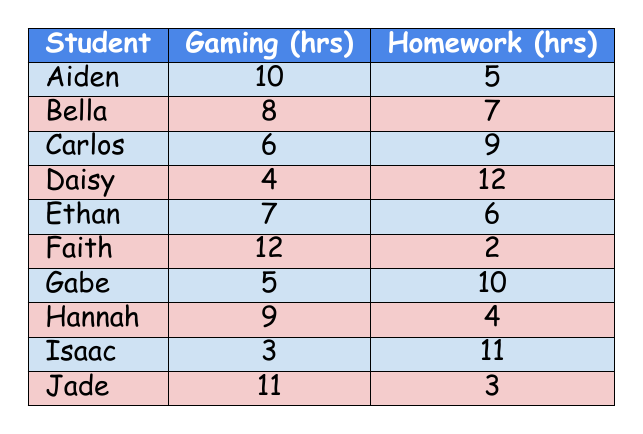What is the total number of hours spent on gaming by all the students? To find the total hours spent on gaming, we add the hours for each student: 10 + 8 + 6 + 4 + 7 + 12 + 5 + 9 + 3 + 11 = 75.
Answer: 75 How many students spent more hours on homework than on gaming? We compare the hours of gaming and homework for each student. The students are Carlos, Daisy, Gabe, and Isaac, as they spent 9, 12, 10, and 11 hours on homework respectively, which are all greater than their gaming hours (6, 4, 5, and 3 hours). This gives us a total of 4 students.
Answer: 4 What is the average number of hours spent on homework by the students? We need to find the total hours spent on homework first. Adding them gives us: 5 + 7 + 9 + 12 + 6 + 2 + 10 + 4 + 11 + 3 = 69. There are 10 students, so the average is 69 divided by 10 = 6.9 hours.
Answer: 6.9 Is there a student who spent 12 hours on gaming? By checking the hours of gaming, we see that the maximum is 12 hours (by Faith), which confirms that this is true.
Answer: Yes Who spent the most time gaming and how many hours did they spend? Looking at the 'Hours_Spent_Gaming' column, we find that Faith spent the most time gaming, which is 12 hours.
Answer: Faith, 12 hours What is the difference between the highest and lowest hours spent on homework? The student who did the least homework was Faith with 2 hours, and the one who did the most was Daisy with 12 hours. The difference is 12 - 2 = 10 hours.
Answer: 10 How many students spent at least 8 hours on gaming? The students who spent 8 or more hours gaming are Aiden, Bella, Ethan, Faith, and Jade. Counting these gives us a total of 5 students.
Answer: 5 Which student had the lowest hours on homework, and what were those hours? The student with the lowest hours on homework is Faith with 2 hours.
Answer: Faith, 2 hours What is the total number of hours spent on both gaming and homework by the students? We add the hours spent on gaming and homework together for each student: (10+5) + (8+7) + (6+9) + (4+12) + (7+6) + (12+2) + (5+10) + (9+4) + (3+11) + (11+3) = 75 + 69 = 144 hours total.
Answer: 144 